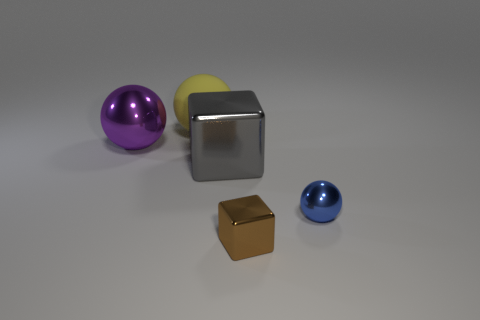Add 2 big green metal spheres. How many objects exist? 7 Subtract all big spheres. How many spheres are left? 1 Subtract all purple balls. How many balls are left? 2 Subtract 1 spheres. How many spheres are left? 2 Add 3 large yellow spheres. How many large yellow spheres are left? 4 Add 4 large objects. How many large objects exist? 7 Subtract 0 yellow cylinders. How many objects are left? 5 Subtract all balls. How many objects are left? 2 Subtract all brown spheres. Subtract all yellow cylinders. How many spheres are left? 3 Subtract all big gray metallic blocks. Subtract all brown things. How many objects are left? 3 